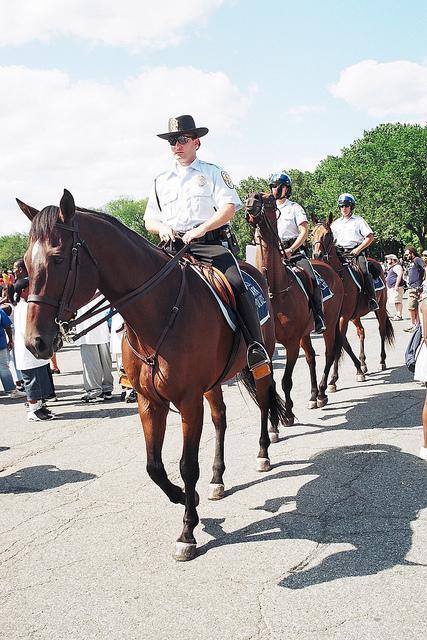How many riders are there?
Give a very brief answer. 3. How many people are visible?
Give a very brief answer. 3. How many horses are in the picture?
Give a very brief answer. 3. 